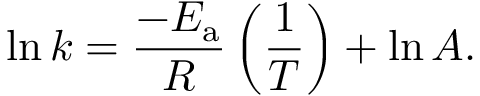Convert formula to latex. <formula><loc_0><loc_0><loc_500><loc_500>\ln k = { \frac { - E _ { a } } { R } } \left ( { \frac { 1 } { T } } \right ) + \ln A .</formula> 